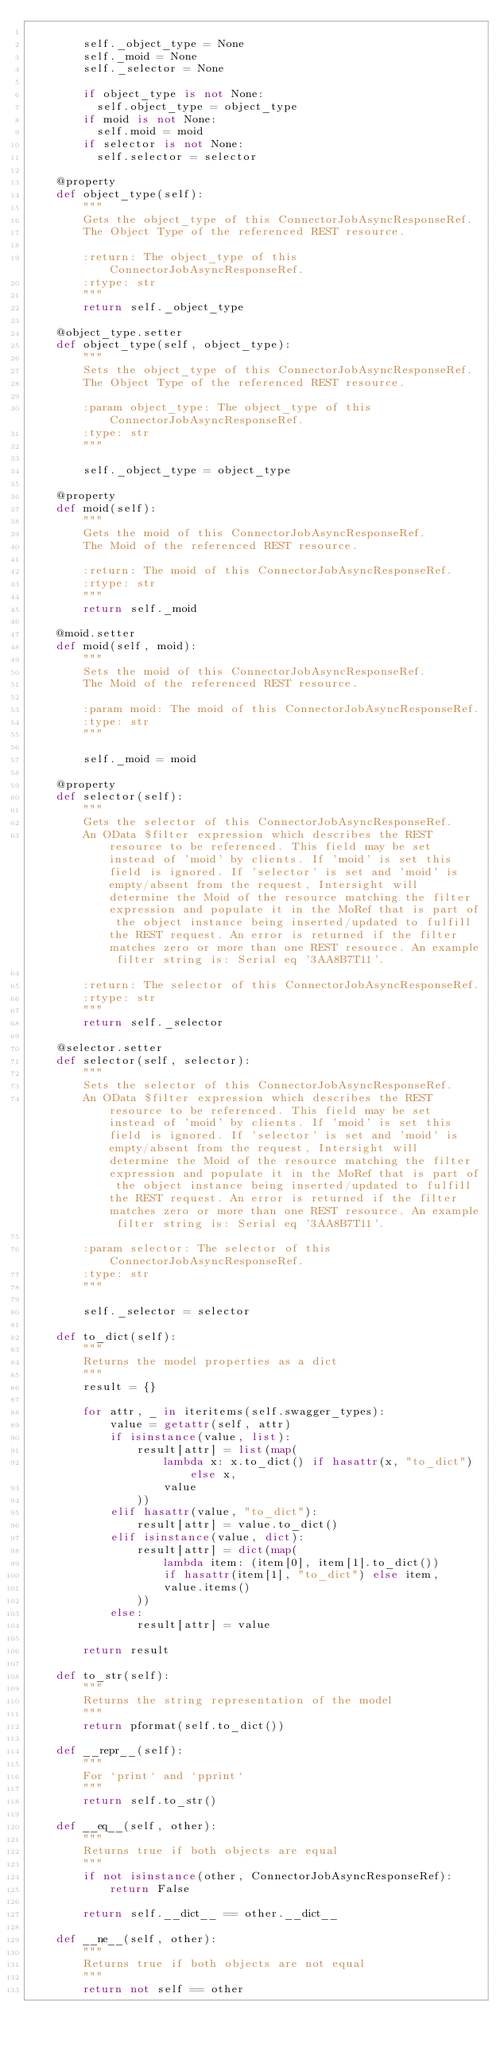<code> <loc_0><loc_0><loc_500><loc_500><_Python_>
        self._object_type = None
        self._moid = None
        self._selector = None

        if object_type is not None:
          self.object_type = object_type
        if moid is not None:
          self.moid = moid
        if selector is not None:
          self.selector = selector

    @property
    def object_type(self):
        """
        Gets the object_type of this ConnectorJobAsyncResponseRef.
        The Object Type of the referenced REST resource.

        :return: The object_type of this ConnectorJobAsyncResponseRef.
        :rtype: str
        """
        return self._object_type

    @object_type.setter
    def object_type(self, object_type):
        """
        Sets the object_type of this ConnectorJobAsyncResponseRef.
        The Object Type of the referenced REST resource.

        :param object_type: The object_type of this ConnectorJobAsyncResponseRef.
        :type: str
        """

        self._object_type = object_type

    @property
    def moid(self):
        """
        Gets the moid of this ConnectorJobAsyncResponseRef.
        The Moid of the referenced REST resource.

        :return: The moid of this ConnectorJobAsyncResponseRef.
        :rtype: str
        """
        return self._moid

    @moid.setter
    def moid(self, moid):
        """
        Sets the moid of this ConnectorJobAsyncResponseRef.
        The Moid of the referenced REST resource.

        :param moid: The moid of this ConnectorJobAsyncResponseRef.
        :type: str
        """

        self._moid = moid

    @property
    def selector(self):
        """
        Gets the selector of this ConnectorJobAsyncResponseRef.
        An OData $filter expression which describes the REST resource to be referenced. This field may be set instead of 'moid' by clients. If 'moid' is set this field is ignored. If 'selector' is set and 'moid' is empty/absent from the request, Intersight will determine the Moid of the resource matching the filter expression and populate it in the MoRef that is part of the object instance being inserted/updated to fulfill the REST request. An error is returned if the filter matches zero or more than one REST resource. An example filter string is: Serial eq '3AA8B7T11'.

        :return: The selector of this ConnectorJobAsyncResponseRef.
        :rtype: str
        """
        return self._selector

    @selector.setter
    def selector(self, selector):
        """
        Sets the selector of this ConnectorJobAsyncResponseRef.
        An OData $filter expression which describes the REST resource to be referenced. This field may be set instead of 'moid' by clients. If 'moid' is set this field is ignored. If 'selector' is set and 'moid' is empty/absent from the request, Intersight will determine the Moid of the resource matching the filter expression and populate it in the MoRef that is part of the object instance being inserted/updated to fulfill the REST request. An error is returned if the filter matches zero or more than one REST resource. An example filter string is: Serial eq '3AA8B7T11'.

        :param selector: The selector of this ConnectorJobAsyncResponseRef.
        :type: str
        """

        self._selector = selector

    def to_dict(self):
        """
        Returns the model properties as a dict
        """
        result = {}

        for attr, _ in iteritems(self.swagger_types):
            value = getattr(self, attr)
            if isinstance(value, list):
                result[attr] = list(map(
                    lambda x: x.to_dict() if hasattr(x, "to_dict") else x,
                    value
                ))
            elif hasattr(value, "to_dict"):
                result[attr] = value.to_dict()
            elif isinstance(value, dict):
                result[attr] = dict(map(
                    lambda item: (item[0], item[1].to_dict())
                    if hasattr(item[1], "to_dict") else item,
                    value.items()
                ))
            else:
                result[attr] = value

        return result

    def to_str(self):
        """
        Returns the string representation of the model
        """
        return pformat(self.to_dict())

    def __repr__(self):
        """
        For `print` and `pprint`
        """
        return self.to_str()

    def __eq__(self, other):
        """
        Returns true if both objects are equal
        """
        if not isinstance(other, ConnectorJobAsyncResponseRef):
            return False

        return self.__dict__ == other.__dict__

    def __ne__(self, other):
        """
        Returns true if both objects are not equal
        """
        return not self == other
</code> 